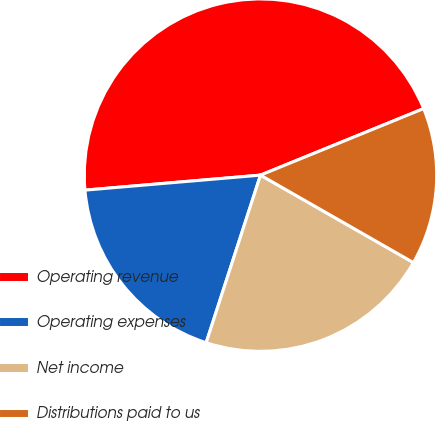Convert chart. <chart><loc_0><loc_0><loc_500><loc_500><pie_chart><fcel>Operating revenue<fcel>Operating expenses<fcel>Net income<fcel>Distributions paid to us<nl><fcel>45.19%<fcel>18.65%<fcel>21.72%<fcel>14.43%<nl></chart> 